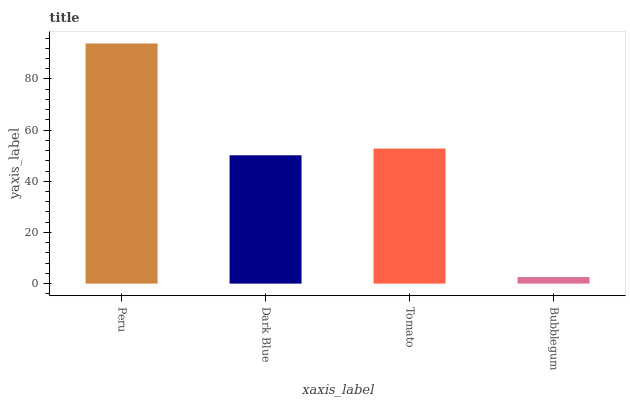Is Bubblegum the minimum?
Answer yes or no. Yes. Is Peru the maximum?
Answer yes or no. Yes. Is Dark Blue the minimum?
Answer yes or no. No. Is Dark Blue the maximum?
Answer yes or no. No. Is Peru greater than Dark Blue?
Answer yes or no. Yes. Is Dark Blue less than Peru?
Answer yes or no. Yes. Is Dark Blue greater than Peru?
Answer yes or no. No. Is Peru less than Dark Blue?
Answer yes or no. No. Is Tomato the high median?
Answer yes or no. Yes. Is Dark Blue the low median?
Answer yes or no. Yes. Is Dark Blue the high median?
Answer yes or no. No. Is Tomato the low median?
Answer yes or no. No. 